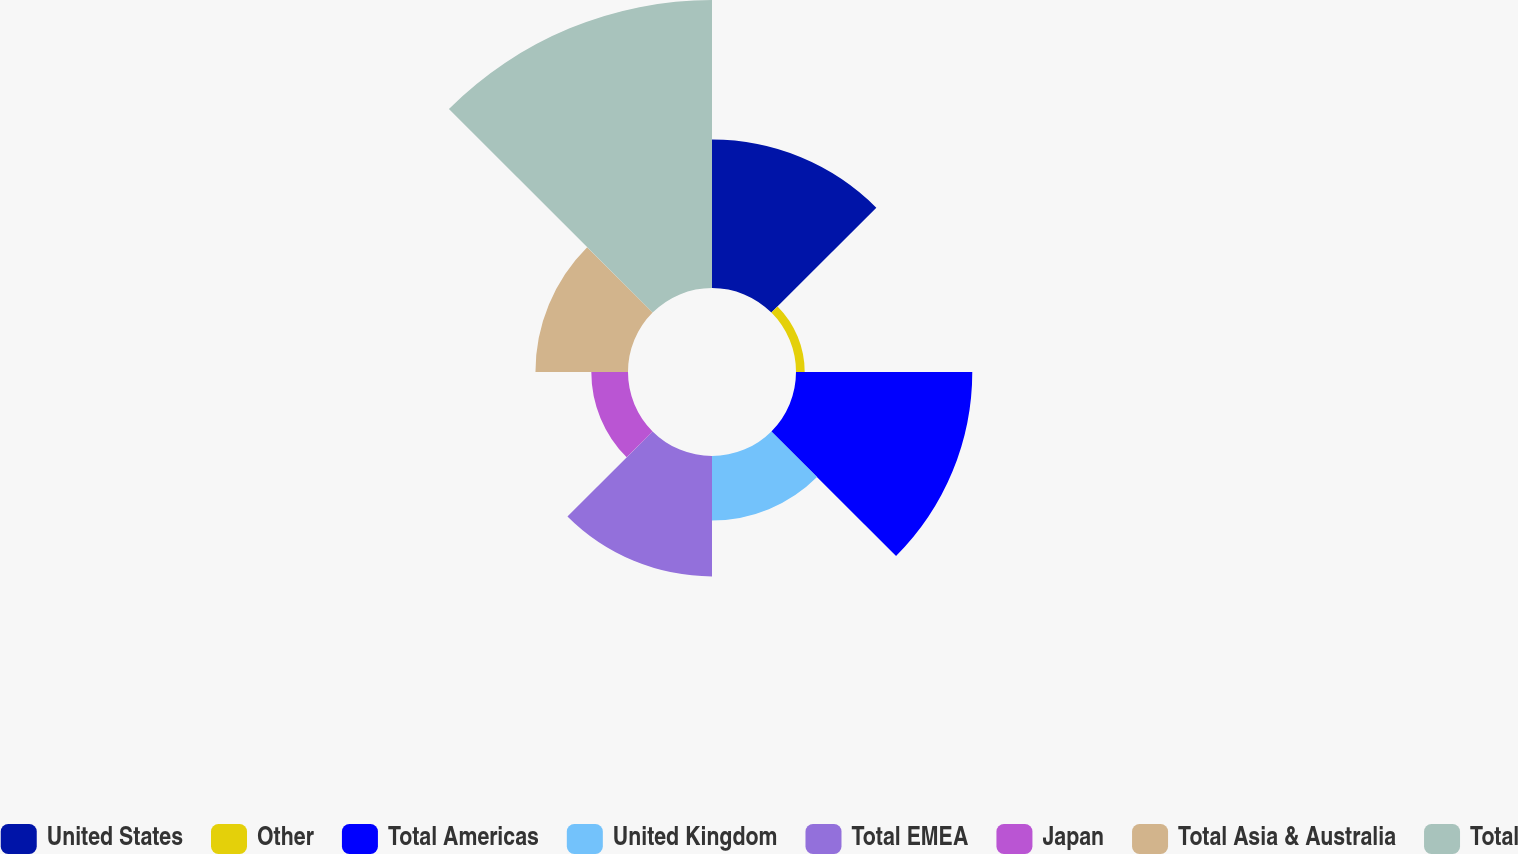Convert chart. <chart><loc_0><loc_0><loc_500><loc_500><pie_chart><fcel>United States<fcel>Other<fcel>Total Americas<fcel>United Kingdom<fcel>Total EMEA<fcel>Japan<fcel>Total Asia & Australia<fcel>Total<nl><fcel>15.86%<fcel>0.93%<fcel>18.84%<fcel>6.9%<fcel>12.87%<fcel>3.92%<fcel>9.89%<fcel>30.78%<nl></chart> 